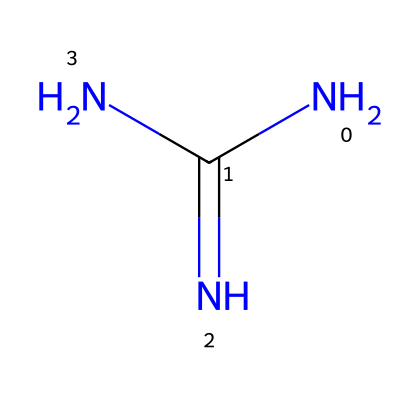What is the molecular formula of guanidine? By interpreting the SMILES representation (NC(=N)N), we can identify that guanidine consists of one carbon atom (C), four hydrogen atoms (H), and three nitrogen atoms (N). The molecular formula is constructed by counting these atoms and organizing them in the standard format.
Answer: C1H4N3 How many nitrogen atoms are present in guanidine? The SMILES notation shows three nitrogen atoms (N) in its structure, identified from the 'N' characters present. Counting each occurrence gives a total of three nitrogen atoms.
Answer: 3 What is the hybridization of the carbon atom in guanidine? Analyzing the structure from the SMILES, we see the carbon (C) is bonded to two nitrogen atoms with a cotangent and one nitrogen atom with a single bond, indicating it has three sigma bonds. Thus, the carbon is sp2 hybridized because it has three regions of electron density.
Answer: sp2 Is guanidine a strong base? Guanidine has a high basicity characteristic, as indicated by its ability to accept protons readily compared to many organic compounds. This is also supported by its structural properties, which favor strong interactions with protons.
Answer: yes What type of bonding is present between carbon and nitrogen in guanidine? The SMILES notation indicates both single and double bonds between carbon and nitrogen atoms. The carbon engages in a double bond with one nitrogen (N) and single bonds with the other two, which indicates different types of covalent bonding in the structure.
Answer: covalent In what kind of environments can guanidine be typically found? Guanidine is commonly found in natural water sources, as it can originate from the biological breakdown of organic matter and can be introduced into various ecosystems through wastewater. Therefore, its presence can be attributed to both natural and anthropogenic sources.
Answer: natural water sources Why does guanidine have a high pKa value? The high pKa of guanidine comes from the stability of its conjugate acid and the resonance stabilization provided by the nitrogen atoms bonded to the carbon. This resonance allows for a more stabilized positive charge upon protonation, leading to a higher pKa.
Answer: high pKa 